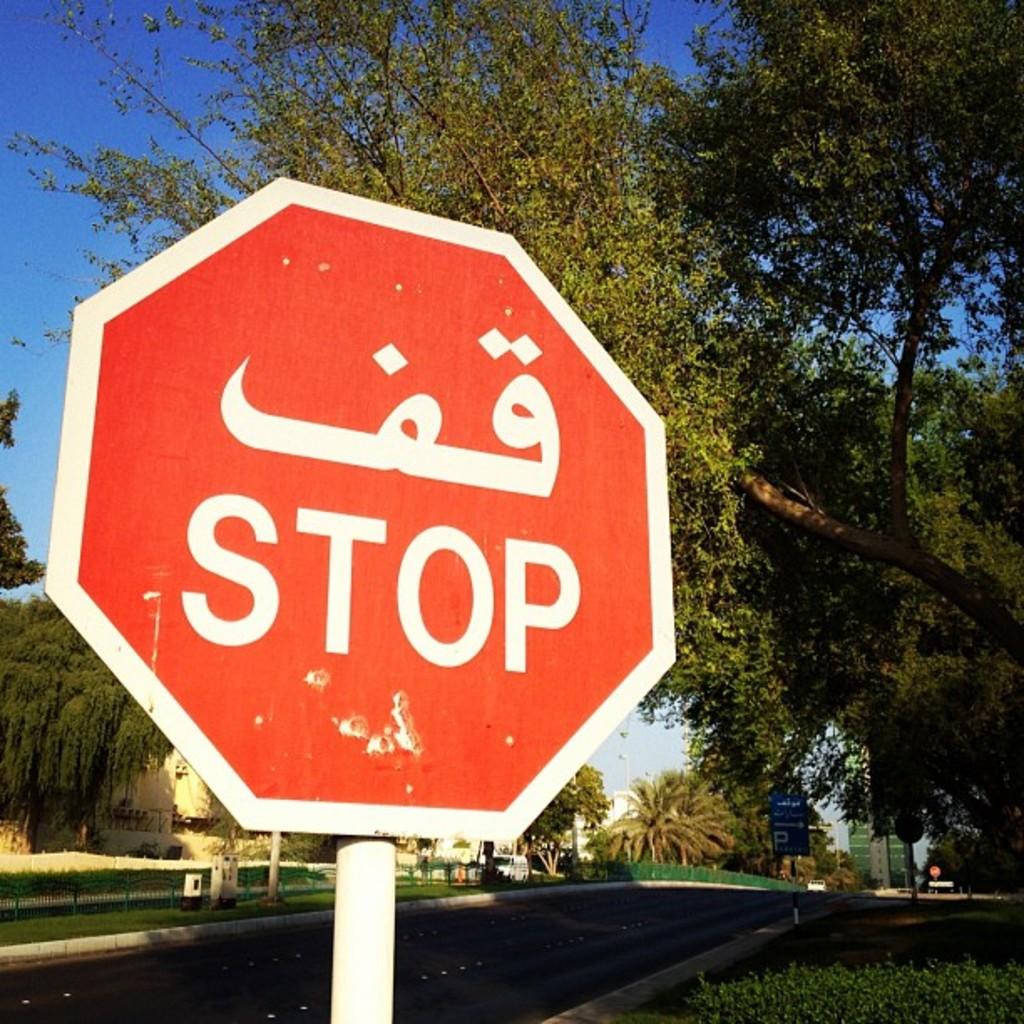What does the sign say?
Provide a short and direct response. Stop. 